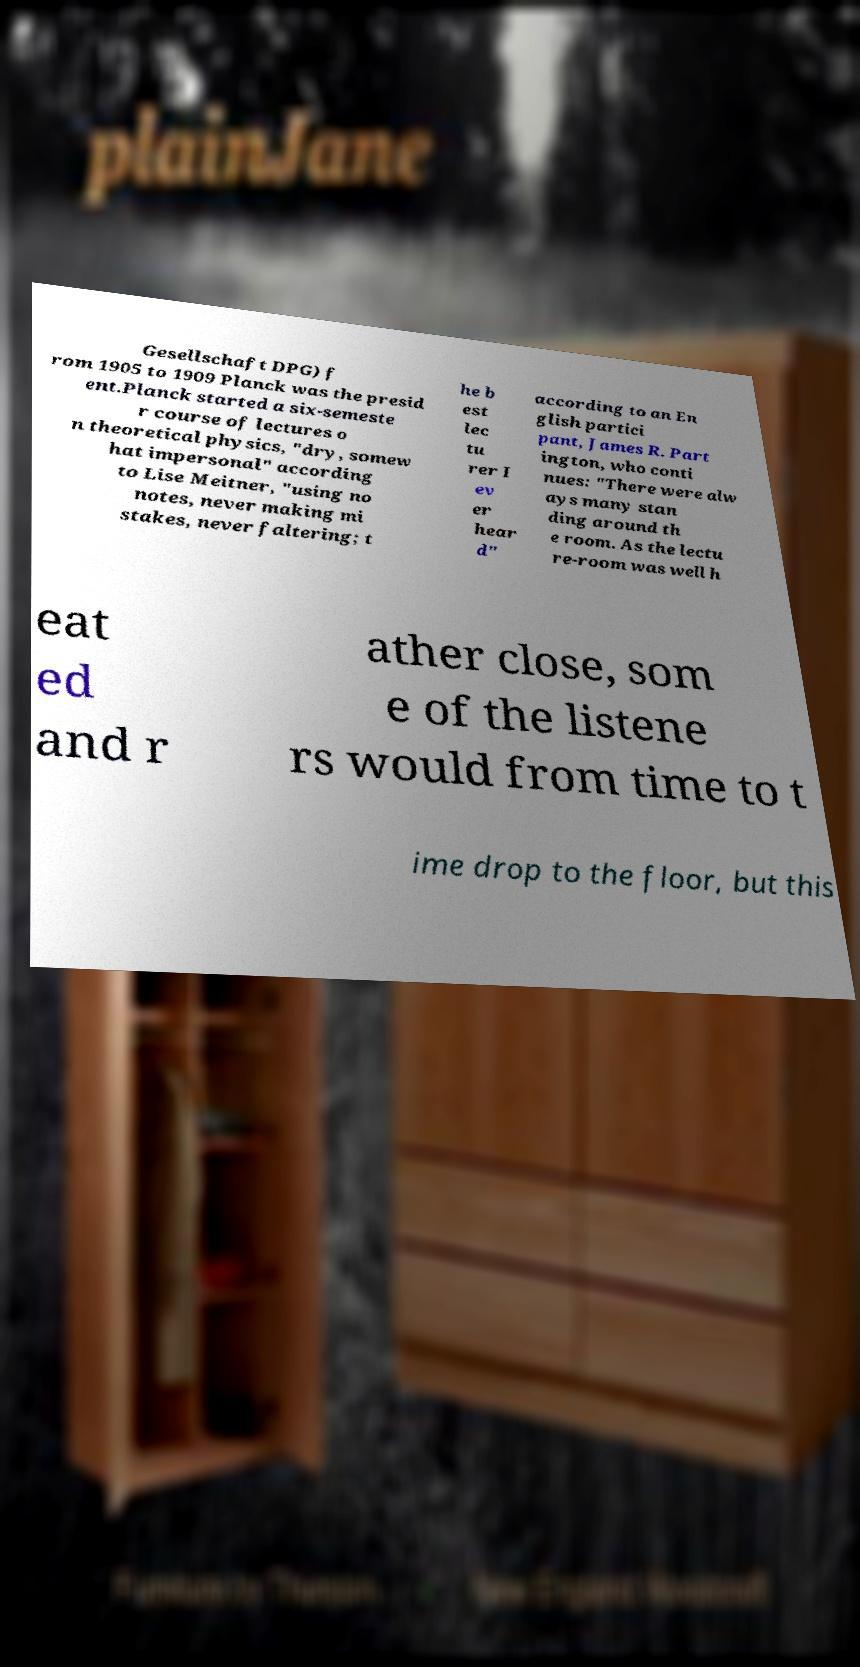Can you read and provide the text displayed in the image?This photo seems to have some interesting text. Can you extract and type it out for me? Gesellschaft DPG) f rom 1905 to 1909 Planck was the presid ent.Planck started a six-semeste r course of lectures o n theoretical physics, "dry, somew hat impersonal" according to Lise Meitner, "using no notes, never making mi stakes, never faltering; t he b est lec tu rer I ev er hear d" according to an En glish partici pant, James R. Part ington, who conti nues: "There were alw ays many stan ding around th e room. As the lectu re-room was well h eat ed and r ather close, som e of the listene rs would from time to t ime drop to the floor, but this 